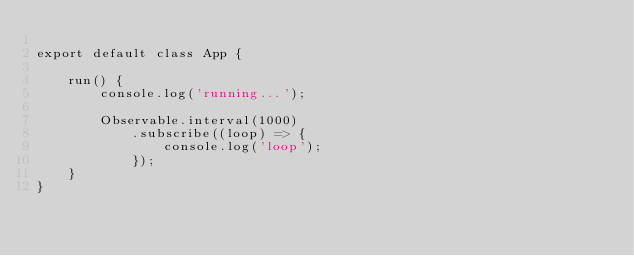Convert code to text. <code><loc_0><loc_0><loc_500><loc_500><_JavaScript_>
export default class App {

    run() {
        console.log('running...');

        Observable.interval(1000)
            .subscribe((loop) => {
                console.log('loop');
            });
    }
}
</code> 